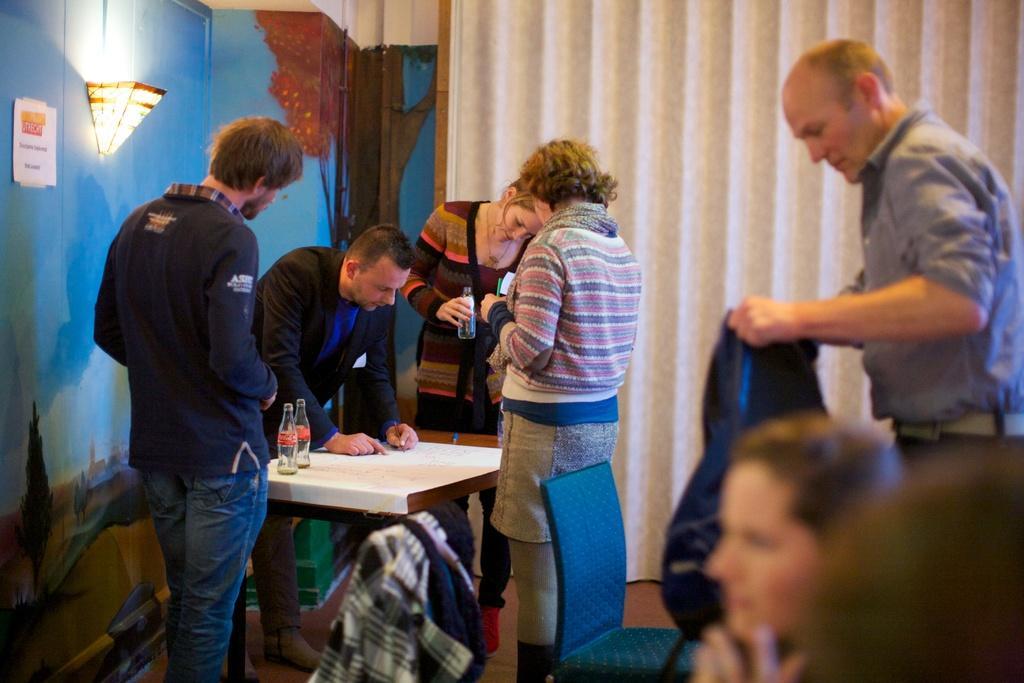Please provide a concise description of this image. We can see here a group of people standing in front of a table and the guy in the center is trying to explain something on the chart and there are bottles present on the table and at the left side on the wall we can see light and at the bottom right we can see people sitting 